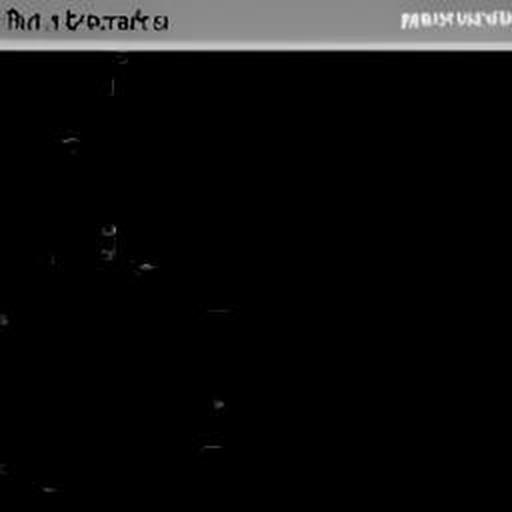Could this image still be used artistically to convey a message or emotion? Certainly, even in its current state, this image could be employed to evoke feelings of mystery, fear, or the unknown. It could represent the concept of 'absence' or 'void' and be used in art installations, experimental media, or thematic storytelling to engage the audience's imagination. 